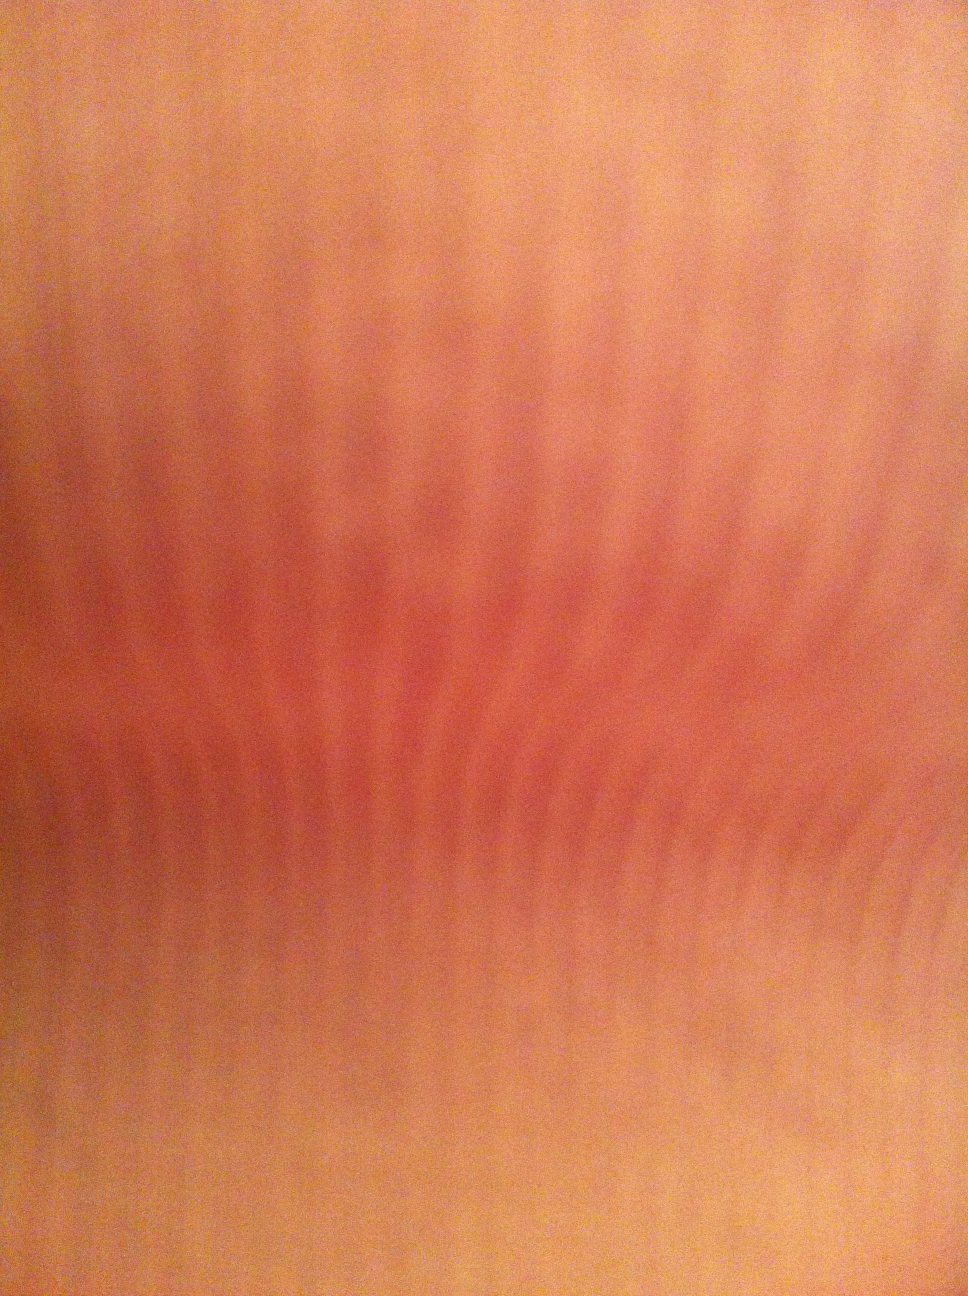What color is this? from Vizwiz orange 